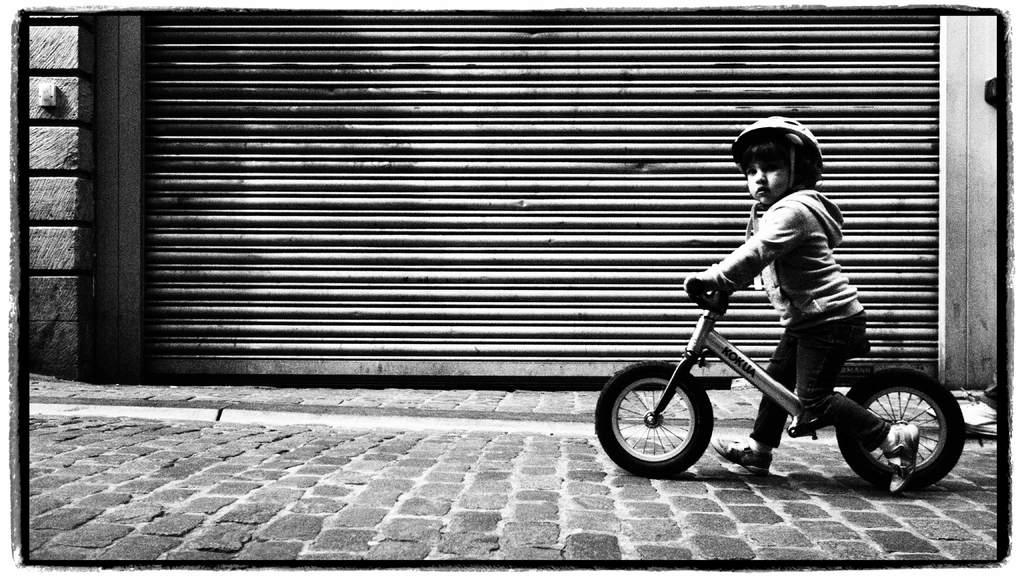Who is the main subject in the image? There is a boy in the image. What is the boy doing in the image? The boy is riding a bicycle. Where is the bicycle located in the image? The bicycle is on the sidewalk. What can be seen in the background of the image? There is a fence in the background of the image. What type of bucket is the boy carrying while riding the bicycle? There is no bucket present in the image; the boy is only riding a bicycle. 